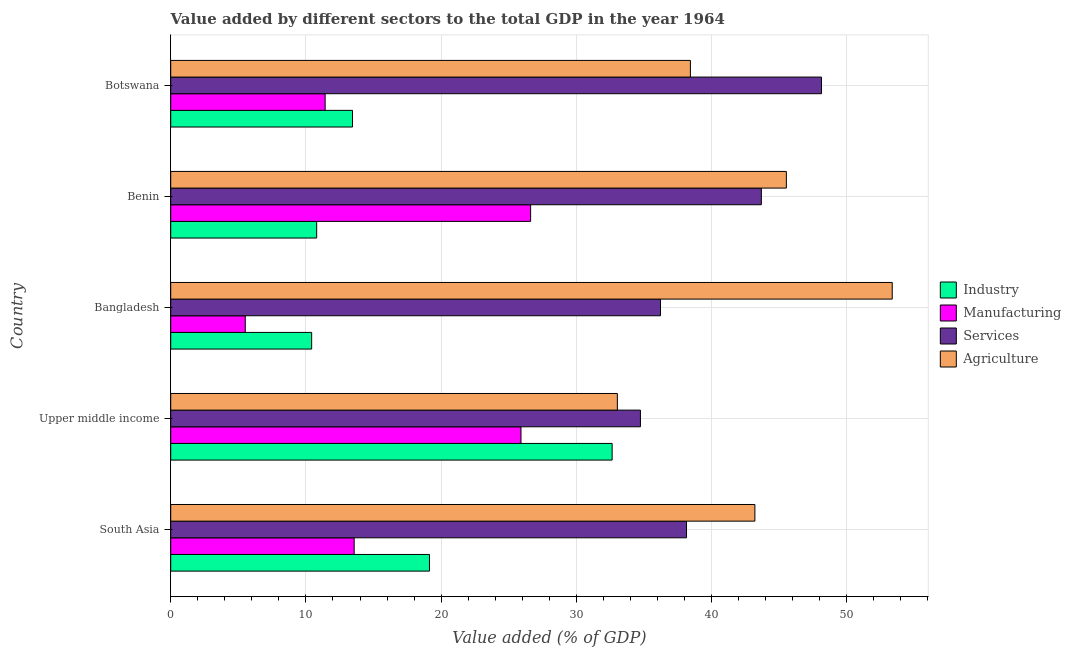What is the label of the 3rd group of bars from the top?
Offer a very short reply. Bangladesh. In how many cases, is the number of bars for a given country not equal to the number of legend labels?
Provide a succinct answer. 0. What is the value added by manufacturing sector in Benin?
Provide a succinct answer. 26.61. Across all countries, what is the maximum value added by industrial sector?
Your response must be concise. 32.64. Across all countries, what is the minimum value added by industrial sector?
Offer a terse response. 10.42. In which country was the value added by industrial sector maximum?
Offer a terse response. Upper middle income. In which country was the value added by agricultural sector minimum?
Your answer should be compact. Upper middle income. What is the total value added by manufacturing sector in the graph?
Offer a very short reply. 83.02. What is the difference between the value added by agricultural sector in Botswana and that in Upper middle income?
Make the answer very short. 5.4. What is the difference between the value added by industrial sector in Bangladesh and the value added by agricultural sector in South Asia?
Your answer should be compact. -32.78. What is the average value added by services sector per country?
Give a very brief answer. 40.18. What is the difference between the value added by manufacturing sector and value added by industrial sector in Botswana?
Give a very brief answer. -2.02. What is the ratio of the value added by agricultural sector in Bangladesh to that in Benin?
Make the answer very short. 1.17. Is the value added by services sector in Bangladesh less than that in Benin?
Provide a succinct answer. Yes. Is the difference between the value added by agricultural sector in Botswana and South Asia greater than the difference between the value added by manufacturing sector in Botswana and South Asia?
Your answer should be very brief. No. What is the difference between the highest and the second highest value added by agricultural sector?
Offer a very short reply. 7.83. What is the difference between the highest and the lowest value added by services sector?
Your answer should be compact. 13.39. In how many countries, is the value added by services sector greater than the average value added by services sector taken over all countries?
Your response must be concise. 2. What does the 4th bar from the top in South Asia represents?
Provide a succinct answer. Industry. What does the 4th bar from the bottom in Botswana represents?
Offer a terse response. Agriculture. Is it the case that in every country, the sum of the value added by industrial sector and value added by manufacturing sector is greater than the value added by services sector?
Provide a succinct answer. No. Are all the bars in the graph horizontal?
Your answer should be compact. Yes. How many countries are there in the graph?
Give a very brief answer. 5. Are the values on the major ticks of X-axis written in scientific E-notation?
Provide a succinct answer. No. Where does the legend appear in the graph?
Keep it short and to the point. Center right. How many legend labels are there?
Offer a very short reply. 4. What is the title of the graph?
Offer a very short reply. Value added by different sectors to the total GDP in the year 1964. Does "Austria" appear as one of the legend labels in the graph?
Ensure brevity in your answer.  No. What is the label or title of the X-axis?
Your response must be concise. Value added (% of GDP). What is the label or title of the Y-axis?
Ensure brevity in your answer.  Country. What is the Value added (% of GDP) in Industry in South Asia?
Provide a short and direct response. 19.13. What is the Value added (% of GDP) of Manufacturing in South Asia?
Offer a very short reply. 13.57. What is the Value added (% of GDP) in Services in South Asia?
Provide a succinct answer. 38.14. What is the Value added (% of GDP) in Agriculture in South Asia?
Offer a very short reply. 43.2. What is the Value added (% of GDP) in Industry in Upper middle income?
Provide a succinct answer. 32.64. What is the Value added (% of GDP) of Manufacturing in Upper middle income?
Offer a terse response. 25.9. What is the Value added (% of GDP) in Services in Upper middle income?
Provide a succinct answer. 34.74. What is the Value added (% of GDP) in Agriculture in Upper middle income?
Your response must be concise. 33.03. What is the Value added (% of GDP) in Industry in Bangladesh?
Your response must be concise. 10.42. What is the Value added (% of GDP) in Manufacturing in Bangladesh?
Ensure brevity in your answer.  5.51. What is the Value added (% of GDP) of Services in Bangladesh?
Offer a terse response. 36.22. What is the Value added (% of GDP) of Agriculture in Bangladesh?
Make the answer very short. 53.36. What is the Value added (% of GDP) in Industry in Benin?
Your response must be concise. 10.79. What is the Value added (% of GDP) in Manufacturing in Benin?
Your response must be concise. 26.61. What is the Value added (% of GDP) in Services in Benin?
Provide a short and direct response. 43.68. What is the Value added (% of GDP) in Agriculture in Benin?
Provide a short and direct response. 45.53. What is the Value added (% of GDP) of Industry in Botswana?
Your answer should be compact. 13.44. What is the Value added (% of GDP) of Manufacturing in Botswana?
Your answer should be compact. 11.42. What is the Value added (% of GDP) of Services in Botswana?
Provide a succinct answer. 48.13. What is the Value added (% of GDP) of Agriculture in Botswana?
Your answer should be very brief. 38.43. Across all countries, what is the maximum Value added (% of GDP) in Industry?
Ensure brevity in your answer.  32.64. Across all countries, what is the maximum Value added (% of GDP) of Manufacturing?
Keep it short and to the point. 26.61. Across all countries, what is the maximum Value added (% of GDP) in Services?
Keep it short and to the point. 48.13. Across all countries, what is the maximum Value added (% of GDP) in Agriculture?
Offer a terse response. 53.36. Across all countries, what is the minimum Value added (% of GDP) in Industry?
Make the answer very short. 10.42. Across all countries, what is the minimum Value added (% of GDP) in Manufacturing?
Give a very brief answer. 5.51. Across all countries, what is the minimum Value added (% of GDP) of Services?
Offer a very short reply. 34.74. Across all countries, what is the minimum Value added (% of GDP) of Agriculture?
Your answer should be compact. 33.03. What is the total Value added (% of GDP) in Industry in the graph?
Provide a succinct answer. 86.44. What is the total Value added (% of GDP) of Manufacturing in the graph?
Ensure brevity in your answer.  83.02. What is the total Value added (% of GDP) in Services in the graph?
Keep it short and to the point. 200.9. What is the total Value added (% of GDP) of Agriculture in the graph?
Give a very brief answer. 213.55. What is the difference between the Value added (% of GDP) in Industry in South Asia and that in Upper middle income?
Offer a very short reply. -13.51. What is the difference between the Value added (% of GDP) in Manufacturing in South Asia and that in Upper middle income?
Your answer should be very brief. -12.34. What is the difference between the Value added (% of GDP) in Services in South Asia and that in Upper middle income?
Give a very brief answer. 3.41. What is the difference between the Value added (% of GDP) of Agriculture in South Asia and that in Upper middle income?
Your answer should be very brief. 10.17. What is the difference between the Value added (% of GDP) of Industry in South Asia and that in Bangladesh?
Your response must be concise. 8.71. What is the difference between the Value added (% of GDP) of Manufacturing in South Asia and that in Bangladesh?
Give a very brief answer. 8.05. What is the difference between the Value added (% of GDP) in Services in South Asia and that in Bangladesh?
Your response must be concise. 1.92. What is the difference between the Value added (% of GDP) in Agriculture in South Asia and that in Bangladesh?
Your answer should be compact. -10.16. What is the difference between the Value added (% of GDP) in Industry in South Asia and that in Benin?
Provide a short and direct response. 8.34. What is the difference between the Value added (% of GDP) of Manufacturing in South Asia and that in Benin?
Your answer should be very brief. -13.05. What is the difference between the Value added (% of GDP) in Services in South Asia and that in Benin?
Your answer should be very brief. -5.54. What is the difference between the Value added (% of GDP) of Agriculture in South Asia and that in Benin?
Your answer should be compact. -2.33. What is the difference between the Value added (% of GDP) of Industry in South Asia and that in Botswana?
Your answer should be compact. 5.69. What is the difference between the Value added (% of GDP) in Manufacturing in South Asia and that in Botswana?
Offer a terse response. 2.15. What is the difference between the Value added (% of GDP) of Services in South Asia and that in Botswana?
Provide a short and direct response. -9.98. What is the difference between the Value added (% of GDP) in Agriculture in South Asia and that in Botswana?
Ensure brevity in your answer.  4.77. What is the difference between the Value added (% of GDP) in Industry in Upper middle income and that in Bangladesh?
Your answer should be compact. 22.22. What is the difference between the Value added (% of GDP) of Manufacturing in Upper middle income and that in Bangladesh?
Give a very brief answer. 20.39. What is the difference between the Value added (% of GDP) in Services in Upper middle income and that in Bangladesh?
Offer a very short reply. -1.48. What is the difference between the Value added (% of GDP) of Agriculture in Upper middle income and that in Bangladesh?
Make the answer very short. -20.33. What is the difference between the Value added (% of GDP) of Industry in Upper middle income and that in Benin?
Keep it short and to the point. 21.85. What is the difference between the Value added (% of GDP) of Manufacturing in Upper middle income and that in Benin?
Your answer should be compact. -0.71. What is the difference between the Value added (% of GDP) in Services in Upper middle income and that in Benin?
Your response must be concise. -8.94. What is the difference between the Value added (% of GDP) in Agriculture in Upper middle income and that in Benin?
Your answer should be compact. -12.5. What is the difference between the Value added (% of GDP) of Industry in Upper middle income and that in Botswana?
Your answer should be very brief. 19.2. What is the difference between the Value added (% of GDP) in Manufacturing in Upper middle income and that in Botswana?
Your answer should be compact. 14.48. What is the difference between the Value added (% of GDP) in Services in Upper middle income and that in Botswana?
Provide a succinct answer. -13.39. What is the difference between the Value added (% of GDP) of Agriculture in Upper middle income and that in Botswana?
Make the answer very short. -5.4. What is the difference between the Value added (% of GDP) in Industry in Bangladesh and that in Benin?
Your response must be concise. -0.37. What is the difference between the Value added (% of GDP) of Manufacturing in Bangladesh and that in Benin?
Provide a succinct answer. -21.1. What is the difference between the Value added (% of GDP) in Services in Bangladesh and that in Benin?
Provide a succinct answer. -7.46. What is the difference between the Value added (% of GDP) in Agriculture in Bangladesh and that in Benin?
Make the answer very short. 7.83. What is the difference between the Value added (% of GDP) in Industry in Bangladesh and that in Botswana?
Your response must be concise. -3.02. What is the difference between the Value added (% of GDP) in Manufacturing in Bangladesh and that in Botswana?
Ensure brevity in your answer.  -5.91. What is the difference between the Value added (% of GDP) in Services in Bangladesh and that in Botswana?
Your response must be concise. -11.9. What is the difference between the Value added (% of GDP) in Agriculture in Bangladesh and that in Botswana?
Provide a succinct answer. 14.93. What is the difference between the Value added (% of GDP) of Industry in Benin and that in Botswana?
Your response must be concise. -2.65. What is the difference between the Value added (% of GDP) of Manufacturing in Benin and that in Botswana?
Keep it short and to the point. 15.19. What is the difference between the Value added (% of GDP) of Services in Benin and that in Botswana?
Your answer should be very brief. -4.45. What is the difference between the Value added (% of GDP) in Agriculture in Benin and that in Botswana?
Offer a terse response. 7.1. What is the difference between the Value added (% of GDP) of Industry in South Asia and the Value added (% of GDP) of Manufacturing in Upper middle income?
Provide a short and direct response. -6.77. What is the difference between the Value added (% of GDP) of Industry in South Asia and the Value added (% of GDP) of Services in Upper middle income?
Your response must be concise. -15.6. What is the difference between the Value added (% of GDP) of Industry in South Asia and the Value added (% of GDP) of Agriculture in Upper middle income?
Provide a succinct answer. -13.9. What is the difference between the Value added (% of GDP) in Manufacturing in South Asia and the Value added (% of GDP) in Services in Upper middle income?
Provide a succinct answer. -21.17. What is the difference between the Value added (% of GDP) in Manufacturing in South Asia and the Value added (% of GDP) in Agriculture in Upper middle income?
Offer a terse response. -19.46. What is the difference between the Value added (% of GDP) in Services in South Asia and the Value added (% of GDP) in Agriculture in Upper middle income?
Make the answer very short. 5.11. What is the difference between the Value added (% of GDP) of Industry in South Asia and the Value added (% of GDP) of Manufacturing in Bangladesh?
Your answer should be very brief. 13.62. What is the difference between the Value added (% of GDP) in Industry in South Asia and the Value added (% of GDP) in Services in Bangladesh?
Your answer should be compact. -17.09. What is the difference between the Value added (% of GDP) of Industry in South Asia and the Value added (% of GDP) of Agriculture in Bangladesh?
Your answer should be very brief. -34.22. What is the difference between the Value added (% of GDP) in Manufacturing in South Asia and the Value added (% of GDP) in Services in Bangladesh?
Your answer should be very brief. -22.65. What is the difference between the Value added (% of GDP) in Manufacturing in South Asia and the Value added (% of GDP) in Agriculture in Bangladesh?
Your response must be concise. -39.79. What is the difference between the Value added (% of GDP) in Services in South Asia and the Value added (% of GDP) in Agriculture in Bangladesh?
Give a very brief answer. -15.21. What is the difference between the Value added (% of GDP) of Industry in South Asia and the Value added (% of GDP) of Manufacturing in Benin?
Your answer should be compact. -7.48. What is the difference between the Value added (% of GDP) of Industry in South Asia and the Value added (% of GDP) of Services in Benin?
Give a very brief answer. -24.54. What is the difference between the Value added (% of GDP) in Industry in South Asia and the Value added (% of GDP) in Agriculture in Benin?
Provide a succinct answer. -26.39. What is the difference between the Value added (% of GDP) in Manufacturing in South Asia and the Value added (% of GDP) in Services in Benin?
Provide a succinct answer. -30.11. What is the difference between the Value added (% of GDP) of Manufacturing in South Asia and the Value added (% of GDP) of Agriculture in Benin?
Make the answer very short. -31.96. What is the difference between the Value added (% of GDP) of Services in South Asia and the Value added (% of GDP) of Agriculture in Benin?
Offer a very short reply. -7.38. What is the difference between the Value added (% of GDP) in Industry in South Asia and the Value added (% of GDP) in Manufacturing in Botswana?
Make the answer very short. 7.71. What is the difference between the Value added (% of GDP) of Industry in South Asia and the Value added (% of GDP) of Services in Botswana?
Make the answer very short. -28.99. What is the difference between the Value added (% of GDP) of Industry in South Asia and the Value added (% of GDP) of Agriculture in Botswana?
Your response must be concise. -19.3. What is the difference between the Value added (% of GDP) of Manufacturing in South Asia and the Value added (% of GDP) of Services in Botswana?
Provide a succinct answer. -34.56. What is the difference between the Value added (% of GDP) of Manufacturing in South Asia and the Value added (% of GDP) of Agriculture in Botswana?
Your answer should be compact. -24.86. What is the difference between the Value added (% of GDP) in Services in South Asia and the Value added (% of GDP) in Agriculture in Botswana?
Your answer should be compact. -0.29. What is the difference between the Value added (% of GDP) of Industry in Upper middle income and the Value added (% of GDP) of Manufacturing in Bangladesh?
Ensure brevity in your answer.  27.13. What is the difference between the Value added (% of GDP) of Industry in Upper middle income and the Value added (% of GDP) of Services in Bangladesh?
Ensure brevity in your answer.  -3.58. What is the difference between the Value added (% of GDP) of Industry in Upper middle income and the Value added (% of GDP) of Agriculture in Bangladesh?
Your answer should be compact. -20.71. What is the difference between the Value added (% of GDP) of Manufacturing in Upper middle income and the Value added (% of GDP) of Services in Bangladesh?
Keep it short and to the point. -10.32. What is the difference between the Value added (% of GDP) of Manufacturing in Upper middle income and the Value added (% of GDP) of Agriculture in Bangladesh?
Keep it short and to the point. -27.45. What is the difference between the Value added (% of GDP) of Services in Upper middle income and the Value added (% of GDP) of Agriculture in Bangladesh?
Keep it short and to the point. -18.62. What is the difference between the Value added (% of GDP) of Industry in Upper middle income and the Value added (% of GDP) of Manufacturing in Benin?
Your response must be concise. 6.03. What is the difference between the Value added (% of GDP) in Industry in Upper middle income and the Value added (% of GDP) in Services in Benin?
Your answer should be very brief. -11.04. What is the difference between the Value added (% of GDP) of Industry in Upper middle income and the Value added (% of GDP) of Agriculture in Benin?
Offer a very short reply. -12.88. What is the difference between the Value added (% of GDP) in Manufacturing in Upper middle income and the Value added (% of GDP) in Services in Benin?
Your response must be concise. -17.78. What is the difference between the Value added (% of GDP) in Manufacturing in Upper middle income and the Value added (% of GDP) in Agriculture in Benin?
Provide a succinct answer. -19.62. What is the difference between the Value added (% of GDP) in Services in Upper middle income and the Value added (% of GDP) in Agriculture in Benin?
Give a very brief answer. -10.79. What is the difference between the Value added (% of GDP) of Industry in Upper middle income and the Value added (% of GDP) of Manufacturing in Botswana?
Your answer should be very brief. 21.22. What is the difference between the Value added (% of GDP) in Industry in Upper middle income and the Value added (% of GDP) in Services in Botswana?
Your response must be concise. -15.48. What is the difference between the Value added (% of GDP) in Industry in Upper middle income and the Value added (% of GDP) in Agriculture in Botswana?
Ensure brevity in your answer.  -5.79. What is the difference between the Value added (% of GDP) in Manufacturing in Upper middle income and the Value added (% of GDP) in Services in Botswana?
Provide a short and direct response. -22.22. What is the difference between the Value added (% of GDP) in Manufacturing in Upper middle income and the Value added (% of GDP) in Agriculture in Botswana?
Your answer should be compact. -12.53. What is the difference between the Value added (% of GDP) of Services in Upper middle income and the Value added (% of GDP) of Agriculture in Botswana?
Offer a very short reply. -3.69. What is the difference between the Value added (% of GDP) of Industry in Bangladesh and the Value added (% of GDP) of Manufacturing in Benin?
Your answer should be very brief. -16.19. What is the difference between the Value added (% of GDP) in Industry in Bangladesh and the Value added (% of GDP) in Services in Benin?
Your response must be concise. -33.26. What is the difference between the Value added (% of GDP) in Industry in Bangladesh and the Value added (% of GDP) in Agriculture in Benin?
Offer a terse response. -35.11. What is the difference between the Value added (% of GDP) of Manufacturing in Bangladesh and the Value added (% of GDP) of Services in Benin?
Your response must be concise. -38.16. What is the difference between the Value added (% of GDP) in Manufacturing in Bangladesh and the Value added (% of GDP) in Agriculture in Benin?
Ensure brevity in your answer.  -40.01. What is the difference between the Value added (% of GDP) of Services in Bangladesh and the Value added (% of GDP) of Agriculture in Benin?
Your answer should be compact. -9.31. What is the difference between the Value added (% of GDP) of Industry in Bangladesh and the Value added (% of GDP) of Manufacturing in Botswana?
Provide a short and direct response. -1. What is the difference between the Value added (% of GDP) in Industry in Bangladesh and the Value added (% of GDP) in Services in Botswana?
Your response must be concise. -37.7. What is the difference between the Value added (% of GDP) of Industry in Bangladesh and the Value added (% of GDP) of Agriculture in Botswana?
Offer a very short reply. -28.01. What is the difference between the Value added (% of GDP) of Manufacturing in Bangladesh and the Value added (% of GDP) of Services in Botswana?
Ensure brevity in your answer.  -42.61. What is the difference between the Value added (% of GDP) in Manufacturing in Bangladesh and the Value added (% of GDP) in Agriculture in Botswana?
Your response must be concise. -32.92. What is the difference between the Value added (% of GDP) in Services in Bangladesh and the Value added (% of GDP) in Agriculture in Botswana?
Make the answer very short. -2.21. What is the difference between the Value added (% of GDP) in Industry in Benin and the Value added (% of GDP) in Manufacturing in Botswana?
Offer a very short reply. -0.63. What is the difference between the Value added (% of GDP) of Industry in Benin and the Value added (% of GDP) of Services in Botswana?
Provide a succinct answer. -37.33. What is the difference between the Value added (% of GDP) in Industry in Benin and the Value added (% of GDP) in Agriculture in Botswana?
Keep it short and to the point. -27.64. What is the difference between the Value added (% of GDP) in Manufacturing in Benin and the Value added (% of GDP) in Services in Botswana?
Offer a terse response. -21.51. What is the difference between the Value added (% of GDP) in Manufacturing in Benin and the Value added (% of GDP) in Agriculture in Botswana?
Make the answer very short. -11.82. What is the difference between the Value added (% of GDP) of Services in Benin and the Value added (% of GDP) of Agriculture in Botswana?
Keep it short and to the point. 5.25. What is the average Value added (% of GDP) in Industry per country?
Make the answer very short. 17.29. What is the average Value added (% of GDP) in Manufacturing per country?
Keep it short and to the point. 16.6. What is the average Value added (% of GDP) of Services per country?
Your answer should be compact. 40.18. What is the average Value added (% of GDP) in Agriculture per country?
Make the answer very short. 42.71. What is the difference between the Value added (% of GDP) of Industry and Value added (% of GDP) of Manufacturing in South Asia?
Ensure brevity in your answer.  5.57. What is the difference between the Value added (% of GDP) in Industry and Value added (% of GDP) in Services in South Asia?
Provide a short and direct response. -19.01. What is the difference between the Value added (% of GDP) of Industry and Value added (% of GDP) of Agriculture in South Asia?
Your answer should be very brief. -24.07. What is the difference between the Value added (% of GDP) of Manufacturing and Value added (% of GDP) of Services in South Asia?
Your answer should be very brief. -24.58. What is the difference between the Value added (% of GDP) of Manufacturing and Value added (% of GDP) of Agriculture in South Asia?
Make the answer very short. -29.63. What is the difference between the Value added (% of GDP) in Services and Value added (% of GDP) in Agriculture in South Asia?
Give a very brief answer. -5.06. What is the difference between the Value added (% of GDP) in Industry and Value added (% of GDP) in Manufacturing in Upper middle income?
Provide a succinct answer. 6.74. What is the difference between the Value added (% of GDP) of Industry and Value added (% of GDP) of Services in Upper middle income?
Your answer should be very brief. -2.09. What is the difference between the Value added (% of GDP) of Industry and Value added (% of GDP) of Agriculture in Upper middle income?
Provide a short and direct response. -0.39. What is the difference between the Value added (% of GDP) of Manufacturing and Value added (% of GDP) of Services in Upper middle income?
Your answer should be compact. -8.83. What is the difference between the Value added (% of GDP) in Manufacturing and Value added (% of GDP) in Agriculture in Upper middle income?
Offer a very short reply. -7.13. What is the difference between the Value added (% of GDP) in Services and Value added (% of GDP) in Agriculture in Upper middle income?
Keep it short and to the point. 1.71. What is the difference between the Value added (% of GDP) of Industry and Value added (% of GDP) of Manufacturing in Bangladesh?
Your answer should be very brief. 4.91. What is the difference between the Value added (% of GDP) in Industry and Value added (% of GDP) in Services in Bangladesh?
Give a very brief answer. -25.8. What is the difference between the Value added (% of GDP) in Industry and Value added (% of GDP) in Agriculture in Bangladesh?
Provide a short and direct response. -42.93. What is the difference between the Value added (% of GDP) of Manufacturing and Value added (% of GDP) of Services in Bangladesh?
Provide a succinct answer. -30.71. What is the difference between the Value added (% of GDP) of Manufacturing and Value added (% of GDP) of Agriculture in Bangladesh?
Give a very brief answer. -47.84. What is the difference between the Value added (% of GDP) of Services and Value added (% of GDP) of Agriculture in Bangladesh?
Ensure brevity in your answer.  -17.14. What is the difference between the Value added (% of GDP) in Industry and Value added (% of GDP) in Manufacturing in Benin?
Offer a terse response. -15.82. What is the difference between the Value added (% of GDP) in Industry and Value added (% of GDP) in Services in Benin?
Provide a succinct answer. -32.88. What is the difference between the Value added (% of GDP) of Industry and Value added (% of GDP) of Agriculture in Benin?
Ensure brevity in your answer.  -34.73. What is the difference between the Value added (% of GDP) of Manufacturing and Value added (% of GDP) of Services in Benin?
Offer a very short reply. -17.06. What is the difference between the Value added (% of GDP) of Manufacturing and Value added (% of GDP) of Agriculture in Benin?
Provide a succinct answer. -18.91. What is the difference between the Value added (% of GDP) of Services and Value added (% of GDP) of Agriculture in Benin?
Offer a very short reply. -1.85. What is the difference between the Value added (% of GDP) in Industry and Value added (% of GDP) in Manufacturing in Botswana?
Provide a short and direct response. 2.02. What is the difference between the Value added (% of GDP) of Industry and Value added (% of GDP) of Services in Botswana?
Your response must be concise. -34.68. What is the difference between the Value added (% of GDP) of Industry and Value added (% of GDP) of Agriculture in Botswana?
Give a very brief answer. -24.99. What is the difference between the Value added (% of GDP) in Manufacturing and Value added (% of GDP) in Services in Botswana?
Your response must be concise. -36.7. What is the difference between the Value added (% of GDP) of Manufacturing and Value added (% of GDP) of Agriculture in Botswana?
Your answer should be compact. -27.01. What is the difference between the Value added (% of GDP) in Services and Value added (% of GDP) in Agriculture in Botswana?
Provide a succinct answer. 9.69. What is the ratio of the Value added (% of GDP) of Industry in South Asia to that in Upper middle income?
Give a very brief answer. 0.59. What is the ratio of the Value added (% of GDP) of Manufacturing in South Asia to that in Upper middle income?
Your answer should be compact. 0.52. What is the ratio of the Value added (% of GDP) of Services in South Asia to that in Upper middle income?
Offer a terse response. 1.1. What is the ratio of the Value added (% of GDP) in Agriculture in South Asia to that in Upper middle income?
Make the answer very short. 1.31. What is the ratio of the Value added (% of GDP) in Industry in South Asia to that in Bangladesh?
Give a very brief answer. 1.84. What is the ratio of the Value added (% of GDP) in Manufacturing in South Asia to that in Bangladesh?
Offer a very short reply. 2.46. What is the ratio of the Value added (% of GDP) of Services in South Asia to that in Bangladesh?
Offer a terse response. 1.05. What is the ratio of the Value added (% of GDP) in Agriculture in South Asia to that in Bangladesh?
Provide a short and direct response. 0.81. What is the ratio of the Value added (% of GDP) in Industry in South Asia to that in Benin?
Provide a succinct answer. 1.77. What is the ratio of the Value added (% of GDP) of Manufacturing in South Asia to that in Benin?
Give a very brief answer. 0.51. What is the ratio of the Value added (% of GDP) in Services in South Asia to that in Benin?
Provide a succinct answer. 0.87. What is the ratio of the Value added (% of GDP) of Agriculture in South Asia to that in Benin?
Offer a very short reply. 0.95. What is the ratio of the Value added (% of GDP) in Industry in South Asia to that in Botswana?
Give a very brief answer. 1.42. What is the ratio of the Value added (% of GDP) of Manufacturing in South Asia to that in Botswana?
Your answer should be very brief. 1.19. What is the ratio of the Value added (% of GDP) of Services in South Asia to that in Botswana?
Your answer should be very brief. 0.79. What is the ratio of the Value added (% of GDP) of Agriculture in South Asia to that in Botswana?
Make the answer very short. 1.12. What is the ratio of the Value added (% of GDP) in Industry in Upper middle income to that in Bangladesh?
Provide a succinct answer. 3.13. What is the ratio of the Value added (% of GDP) of Manufacturing in Upper middle income to that in Bangladesh?
Ensure brevity in your answer.  4.7. What is the ratio of the Value added (% of GDP) of Services in Upper middle income to that in Bangladesh?
Keep it short and to the point. 0.96. What is the ratio of the Value added (% of GDP) in Agriculture in Upper middle income to that in Bangladesh?
Your answer should be very brief. 0.62. What is the ratio of the Value added (% of GDP) in Industry in Upper middle income to that in Benin?
Offer a terse response. 3.02. What is the ratio of the Value added (% of GDP) in Manufacturing in Upper middle income to that in Benin?
Give a very brief answer. 0.97. What is the ratio of the Value added (% of GDP) in Services in Upper middle income to that in Benin?
Offer a very short reply. 0.8. What is the ratio of the Value added (% of GDP) in Agriculture in Upper middle income to that in Benin?
Provide a succinct answer. 0.73. What is the ratio of the Value added (% of GDP) in Industry in Upper middle income to that in Botswana?
Provide a short and direct response. 2.43. What is the ratio of the Value added (% of GDP) of Manufacturing in Upper middle income to that in Botswana?
Your answer should be very brief. 2.27. What is the ratio of the Value added (% of GDP) of Services in Upper middle income to that in Botswana?
Offer a very short reply. 0.72. What is the ratio of the Value added (% of GDP) of Agriculture in Upper middle income to that in Botswana?
Your answer should be compact. 0.86. What is the ratio of the Value added (% of GDP) of Industry in Bangladesh to that in Benin?
Your answer should be compact. 0.97. What is the ratio of the Value added (% of GDP) in Manufacturing in Bangladesh to that in Benin?
Offer a terse response. 0.21. What is the ratio of the Value added (% of GDP) of Services in Bangladesh to that in Benin?
Offer a very short reply. 0.83. What is the ratio of the Value added (% of GDP) in Agriculture in Bangladesh to that in Benin?
Ensure brevity in your answer.  1.17. What is the ratio of the Value added (% of GDP) in Industry in Bangladesh to that in Botswana?
Your response must be concise. 0.78. What is the ratio of the Value added (% of GDP) of Manufacturing in Bangladesh to that in Botswana?
Your response must be concise. 0.48. What is the ratio of the Value added (% of GDP) in Services in Bangladesh to that in Botswana?
Keep it short and to the point. 0.75. What is the ratio of the Value added (% of GDP) in Agriculture in Bangladesh to that in Botswana?
Offer a very short reply. 1.39. What is the ratio of the Value added (% of GDP) of Industry in Benin to that in Botswana?
Offer a terse response. 0.8. What is the ratio of the Value added (% of GDP) in Manufacturing in Benin to that in Botswana?
Your response must be concise. 2.33. What is the ratio of the Value added (% of GDP) in Services in Benin to that in Botswana?
Your answer should be compact. 0.91. What is the ratio of the Value added (% of GDP) in Agriculture in Benin to that in Botswana?
Offer a terse response. 1.18. What is the difference between the highest and the second highest Value added (% of GDP) in Industry?
Your response must be concise. 13.51. What is the difference between the highest and the second highest Value added (% of GDP) in Manufacturing?
Give a very brief answer. 0.71. What is the difference between the highest and the second highest Value added (% of GDP) in Services?
Offer a terse response. 4.45. What is the difference between the highest and the second highest Value added (% of GDP) in Agriculture?
Provide a succinct answer. 7.83. What is the difference between the highest and the lowest Value added (% of GDP) of Industry?
Keep it short and to the point. 22.22. What is the difference between the highest and the lowest Value added (% of GDP) of Manufacturing?
Keep it short and to the point. 21.1. What is the difference between the highest and the lowest Value added (% of GDP) in Services?
Give a very brief answer. 13.39. What is the difference between the highest and the lowest Value added (% of GDP) of Agriculture?
Make the answer very short. 20.33. 